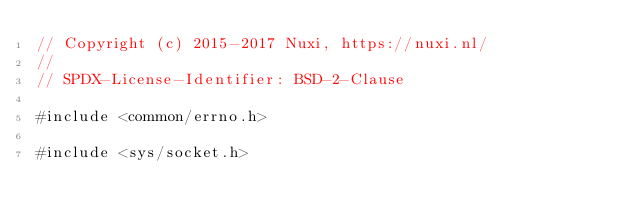Convert code to text. <code><loc_0><loc_0><loc_500><loc_500><_C_>// Copyright (c) 2015-2017 Nuxi, https://nuxi.nl/
//
// SPDX-License-Identifier: BSD-2-Clause

#include <common/errno.h>

#include <sys/socket.h>
</code> 